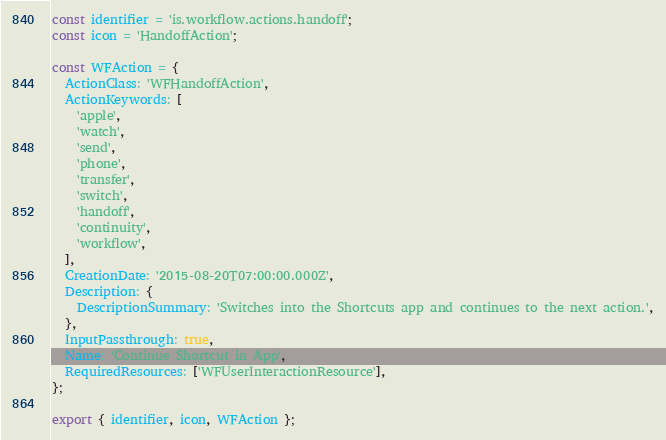<code> <loc_0><loc_0><loc_500><loc_500><_TypeScript_>const identifier = 'is.workflow.actions.handoff';
const icon = 'HandoffAction';

const WFAction = {
  ActionClass: 'WFHandoffAction',
  ActionKeywords: [
    'apple',
    'watch',
    'send',
    'phone',
    'transfer',
    'switch',
    'handoff',
    'continuity',
    'workflow',
  ],
  CreationDate: '2015-08-20T07:00:00.000Z',
  Description: {
    DescriptionSummary: 'Switches into the Shortcuts app and continues to the next action.',
  },
  InputPassthrough: true,
  Name: 'Continue Shortcut in App',
  RequiredResources: ['WFUserInteractionResource'],
};

export { identifier, icon, WFAction };
</code> 